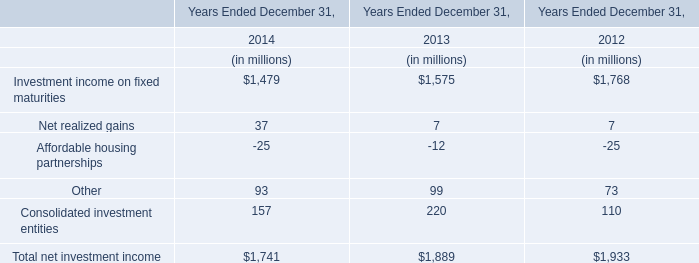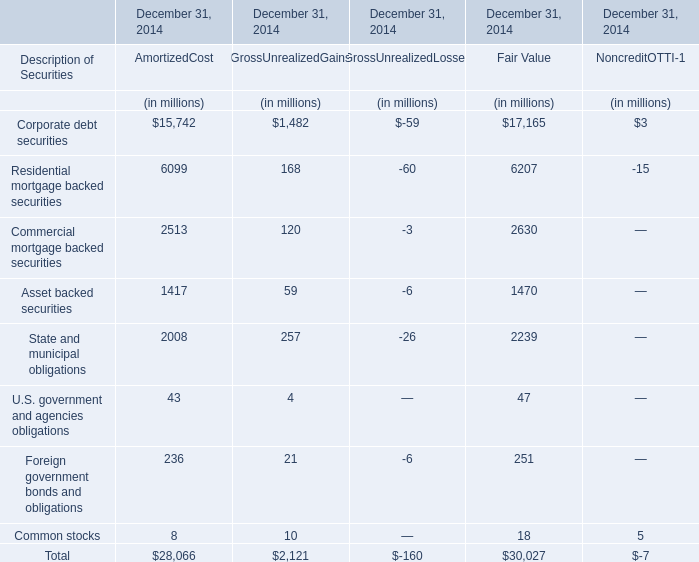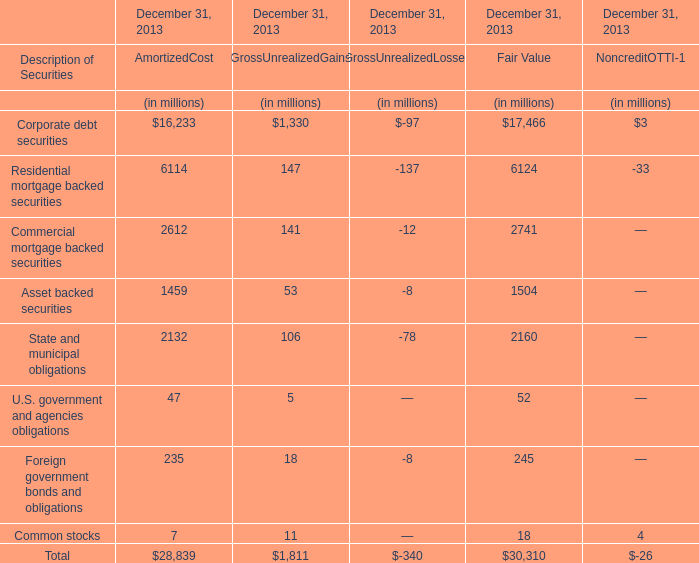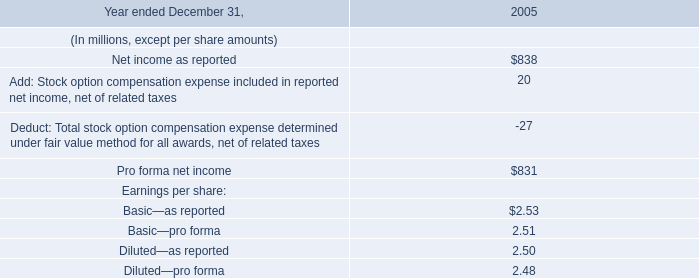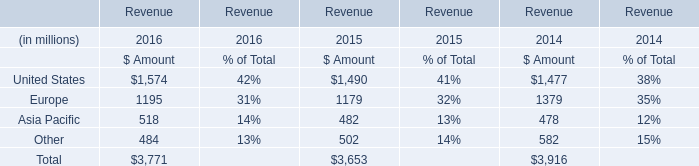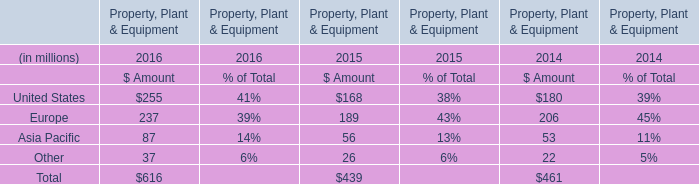What's the total amount of the Investment income on fixed maturities in the years where Net realized gains is greater than 30? (in millions) 
Answer: 1479. 